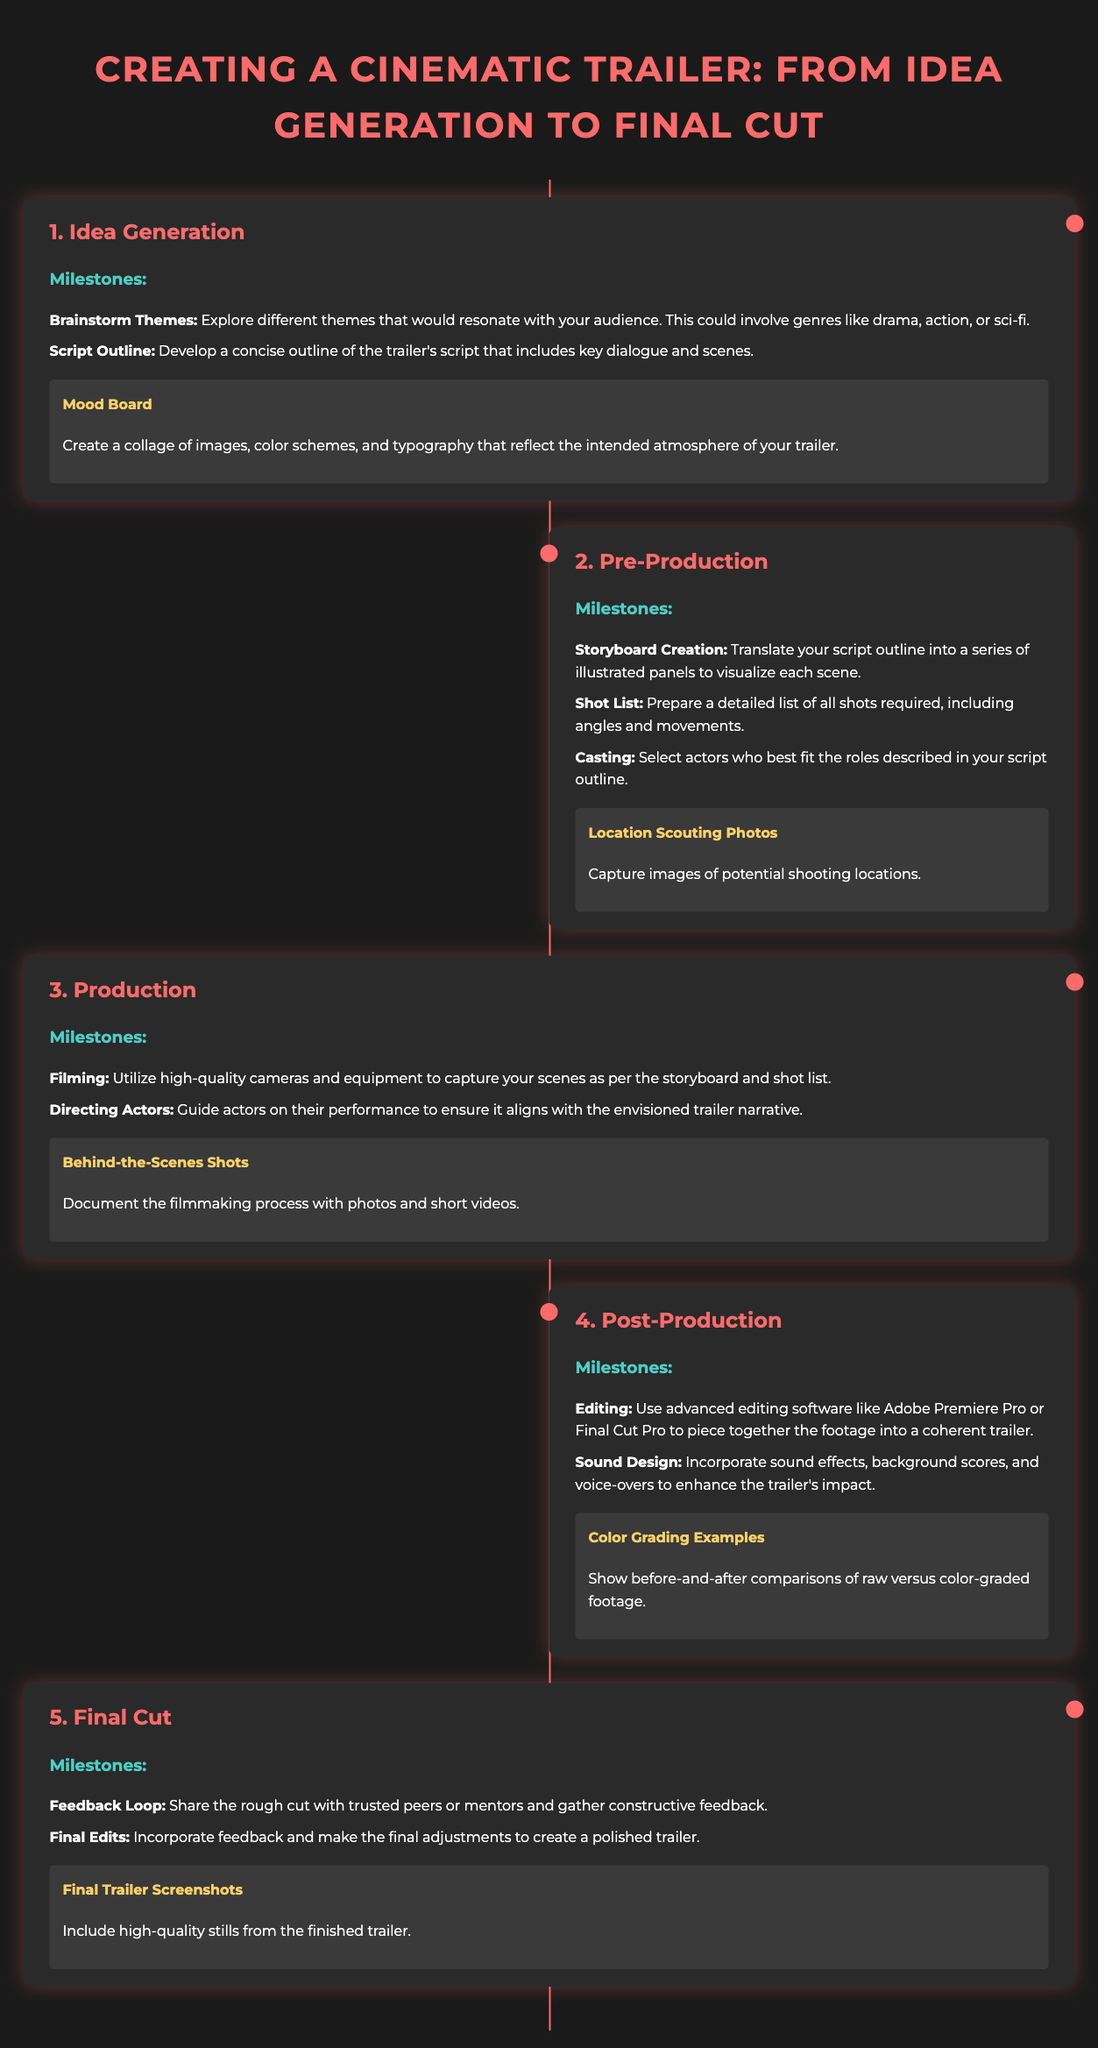What is the first step in creating a cinematic trailer? The first step involves generating ideas and brainstorming themes that resonate with the audience.
Answer: Idea Generation What software is recommended for editing? The document mentions using advanced editing software to piece together footage.
Answer: Adobe Premiere Pro or Final Cut Pro How many main steps are outlined in the infographic? The infographic lists a total of five main steps in the process of creating a cinematic trailer.
Answer: Five What visual element is suggested during the pre-production phase? During pre-production, it is suggested to capture images of potential locations for filming.
Answer: Location Scouting Photos What is the purpose of the mood board? The mood board serves to reflect the intended atmosphere of the trailer through a collage of visual elements.
Answer: To reflect the intended atmosphere What should filmmakers do during the feedback loop in the final cut step? Filmmakers are encouraged to share the rough cut with peers or mentors and gather constructive feedback.
Answer: Gather constructive feedback What type of examples should be shown in post-production? The document suggests showing examples that compare raw footage to color-graded footage to illustrate the editing process.
Answer: Color Grading Examples What is one milestone in the production phase? A key milestone during the production phase involves utilizing high-quality cameras to capture the scenes.
Answer: Filming What color is the background of the document? The background color of the document is specified in the styling section.
Answer: Dark gray (or #1a1a1a) 